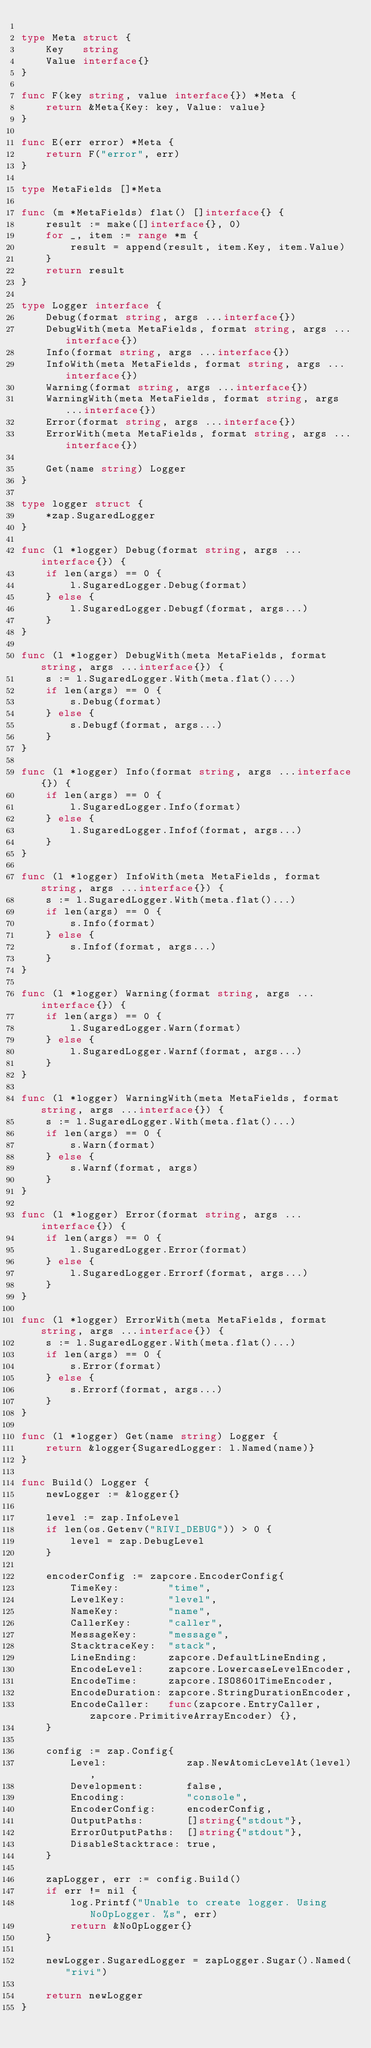<code> <loc_0><loc_0><loc_500><loc_500><_Go_>
type Meta struct {
	Key   string
	Value interface{}
}

func F(key string, value interface{}) *Meta {
	return &Meta{Key: key, Value: value}
}

func E(err error) *Meta {
	return F("error", err)
}

type MetaFields []*Meta

func (m *MetaFields) flat() []interface{} {
	result := make([]interface{}, 0)
	for _, item := range *m {
		result = append(result, item.Key, item.Value)
	}
	return result
}

type Logger interface {
	Debug(format string, args ...interface{})
	DebugWith(meta MetaFields, format string, args ...interface{})
	Info(format string, args ...interface{})
	InfoWith(meta MetaFields, format string, args ...interface{})
	Warning(format string, args ...interface{})
	WarningWith(meta MetaFields, format string, args ...interface{})
	Error(format string, args ...interface{})
	ErrorWith(meta MetaFields, format string, args ...interface{})

	Get(name string) Logger
}

type logger struct {
	*zap.SugaredLogger
}

func (l *logger) Debug(format string, args ...interface{}) {
	if len(args) == 0 {
		l.SugaredLogger.Debug(format)
	} else {
		l.SugaredLogger.Debugf(format, args...)
	}
}

func (l *logger) DebugWith(meta MetaFields, format string, args ...interface{}) {
	s := l.SugaredLogger.With(meta.flat()...)
	if len(args) == 0 {
		s.Debug(format)
	} else {
		s.Debugf(format, args...)
	}
}

func (l *logger) Info(format string, args ...interface{}) {
	if len(args) == 0 {
		l.SugaredLogger.Info(format)
	} else {
		l.SugaredLogger.Infof(format, args...)
	}
}

func (l *logger) InfoWith(meta MetaFields, format string, args ...interface{}) {
	s := l.SugaredLogger.With(meta.flat()...)
	if len(args) == 0 {
		s.Info(format)
	} else {
		s.Infof(format, args...)
	}
}

func (l *logger) Warning(format string, args ...interface{}) {
	if len(args) == 0 {
		l.SugaredLogger.Warn(format)
	} else {
		l.SugaredLogger.Warnf(format, args...)
	}
}

func (l *logger) WarningWith(meta MetaFields, format string, args ...interface{}) {
	s := l.SugaredLogger.With(meta.flat()...)
	if len(args) == 0 {
		s.Warn(format)
	} else {
		s.Warnf(format, args)
	}
}

func (l *logger) Error(format string, args ...interface{}) {
	if len(args) == 0 {
		l.SugaredLogger.Error(format)
	} else {
		l.SugaredLogger.Errorf(format, args...)
	}
}

func (l *logger) ErrorWith(meta MetaFields, format string, args ...interface{}) {
	s := l.SugaredLogger.With(meta.flat()...)
	if len(args) == 0 {
		s.Error(format)
	} else {
		s.Errorf(format, args...)
	}
}

func (l *logger) Get(name string) Logger {
	return &logger{SugaredLogger: l.Named(name)}
}

func Build() Logger {
	newLogger := &logger{}

	level := zap.InfoLevel
	if len(os.Getenv("RIVI_DEBUG")) > 0 {
		level = zap.DebugLevel
	}

	encoderConfig := zapcore.EncoderConfig{
		TimeKey:        "time",
		LevelKey:       "level",
		NameKey:        "name",
		CallerKey:      "caller",
		MessageKey:     "message",
		StacktraceKey:  "stack",
		LineEnding:     zapcore.DefaultLineEnding,
		EncodeLevel:    zapcore.LowercaseLevelEncoder,
		EncodeTime:     zapcore.ISO8601TimeEncoder,
		EncodeDuration: zapcore.StringDurationEncoder,
		EncodeCaller:   func(zapcore.EntryCaller, zapcore.PrimitiveArrayEncoder) {},
	}

	config := zap.Config{
		Level:             zap.NewAtomicLevelAt(level),
		Development:       false,
		Encoding:          "console",
		EncoderConfig:     encoderConfig,
		OutputPaths:       []string{"stdout"},
		ErrorOutputPaths:  []string{"stdout"},
		DisableStacktrace: true,
	}

	zapLogger, err := config.Build()
	if err != nil {
		log.Printf("Unable to create logger. Using NoOpLogger. %s", err)
		return &NoOpLogger{}
	}

	newLogger.SugaredLogger = zapLogger.Sugar().Named("rivi")

	return newLogger
}
</code> 